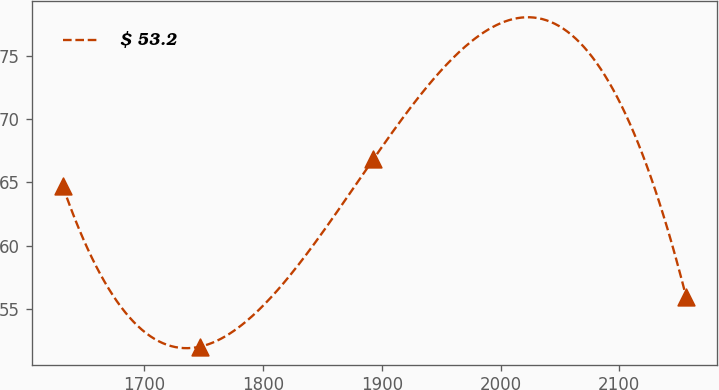Convert chart. <chart><loc_0><loc_0><loc_500><loc_500><line_chart><ecel><fcel>$ 53.2<nl><fcel>1631.14<fcel>64.72<nl><fcel>1747.16<fcel>52.06<nl><fcel>1892.7<fcel>66.81<nl><fcel>2156.27<fcel>55.98<nl></chart> 